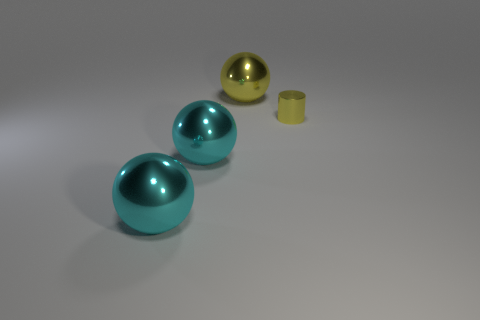Are there any other things that are the same size as the cylinder?
Ensure brevity in your answer.  No. The yellow metal thing right of the shiny object behind the yellow cylinder is what shape?
Ensure brevity in your answer.  Cylinder. Does the tiny yellow thing have the same shape as the large yellow metallic thing?
Your answer should be compact. No. There is a sphere that is the same color as the tiny cylinder; what is its material?
Give a very brief answer. Metal. There is a yellow object that is to the left of the yellow object in front of the big yellow ball; how many tiny yellow objects are behind it?
Your answer should be very brief. 0. There is a yellow object that is made of the same material as the yellow sphere; what is its shape?
Make the answer very short. Cylinder. There is a sphere that is behind the metal object to the right of the metal object that is behind the yellow shiny cylinder; what is it made of?
Offer a terse response. Metal. What number of objects are either yellow things to the right of the big yellow metal sphere or big cyan balls?
Provide a short and direct response. 3. How many other things are the same shape as the large yellow object?
Provide a short and direct response. 2. Are there more objects in front of the tiny yellow cylinder than large cyan metallic things?
Your answer should be very brief. No. 